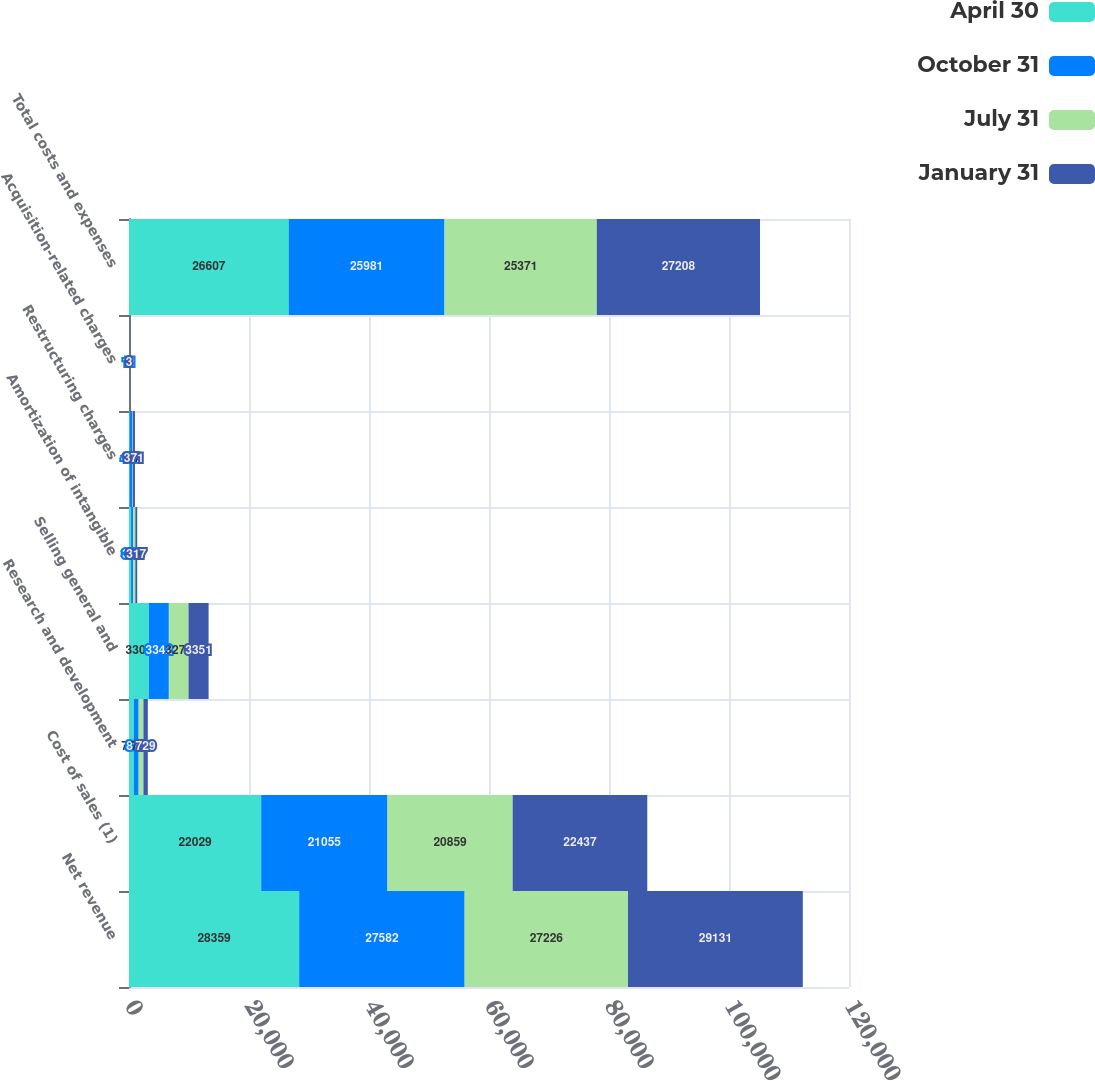<chart> <loc_0><loc_0><loc_500><loc_500><stacked_bar_chart><ecel><fcel>Net revenue<fcel>Cost of sales (1)<fcel>Research and development<fcel>Selling general and<fcel>Amortization of intangible<fcel>Restructuring charges<fcel>Acquisition-related charges<fcel>Total costs and expenses<nl><fcel>April 30<fcel>28359<fcel>22029<fcel>794<fcel>3300<fcel>350<fcel>130<fcel>4<fcel>26607<nl><fcel>October 31<fcel>27582<fcel>21055<fcel>815<fcel>3342<fcel>350<fcel>408<fcel>11<fcel>25981<nl><fcel>July 31<fcel>27226<fcel>20859<fcel>797<fcel>3274<fcel>356<fcel>81<fcel>4<fcel>25371<nl><fcel>January 31<fcel>29131<fcel>22437<fcel>729<fcel>3351<fcel>317<fcel>371<fcel>3<fcel>27208<nl></chart> 